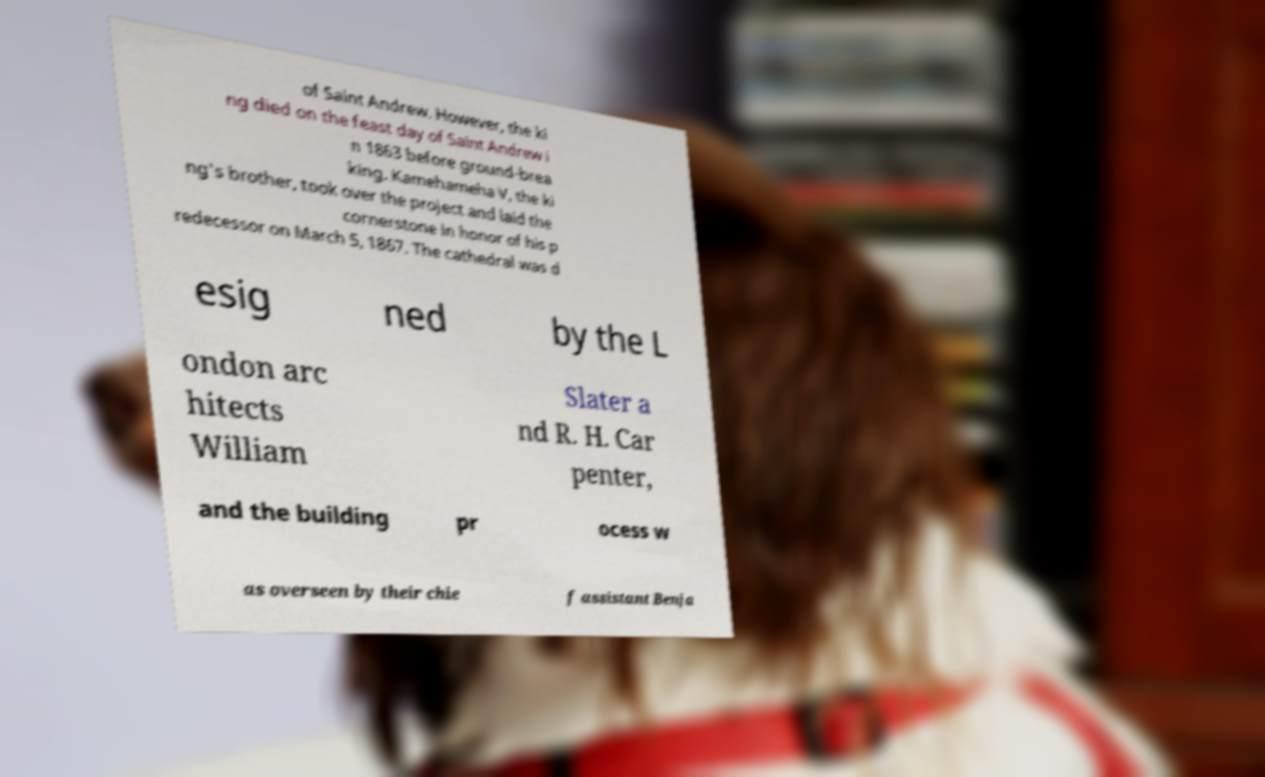Could you extract and type out the text from this image? of Saint Andrew. However, the ki ng died on the feast day of Saint Andrew i n 1863 before ground-brea king. Kamehameha V, the ki ng's brother, took over the project and laid the cornerstone in honor of his p redecessor on March 5, 1867. The cathedral was d esig ned by the L ondon arc hitects William Slater a nd R. H. Car penter, and the building pr ocess w as overseen by their chie f assistant Benja 